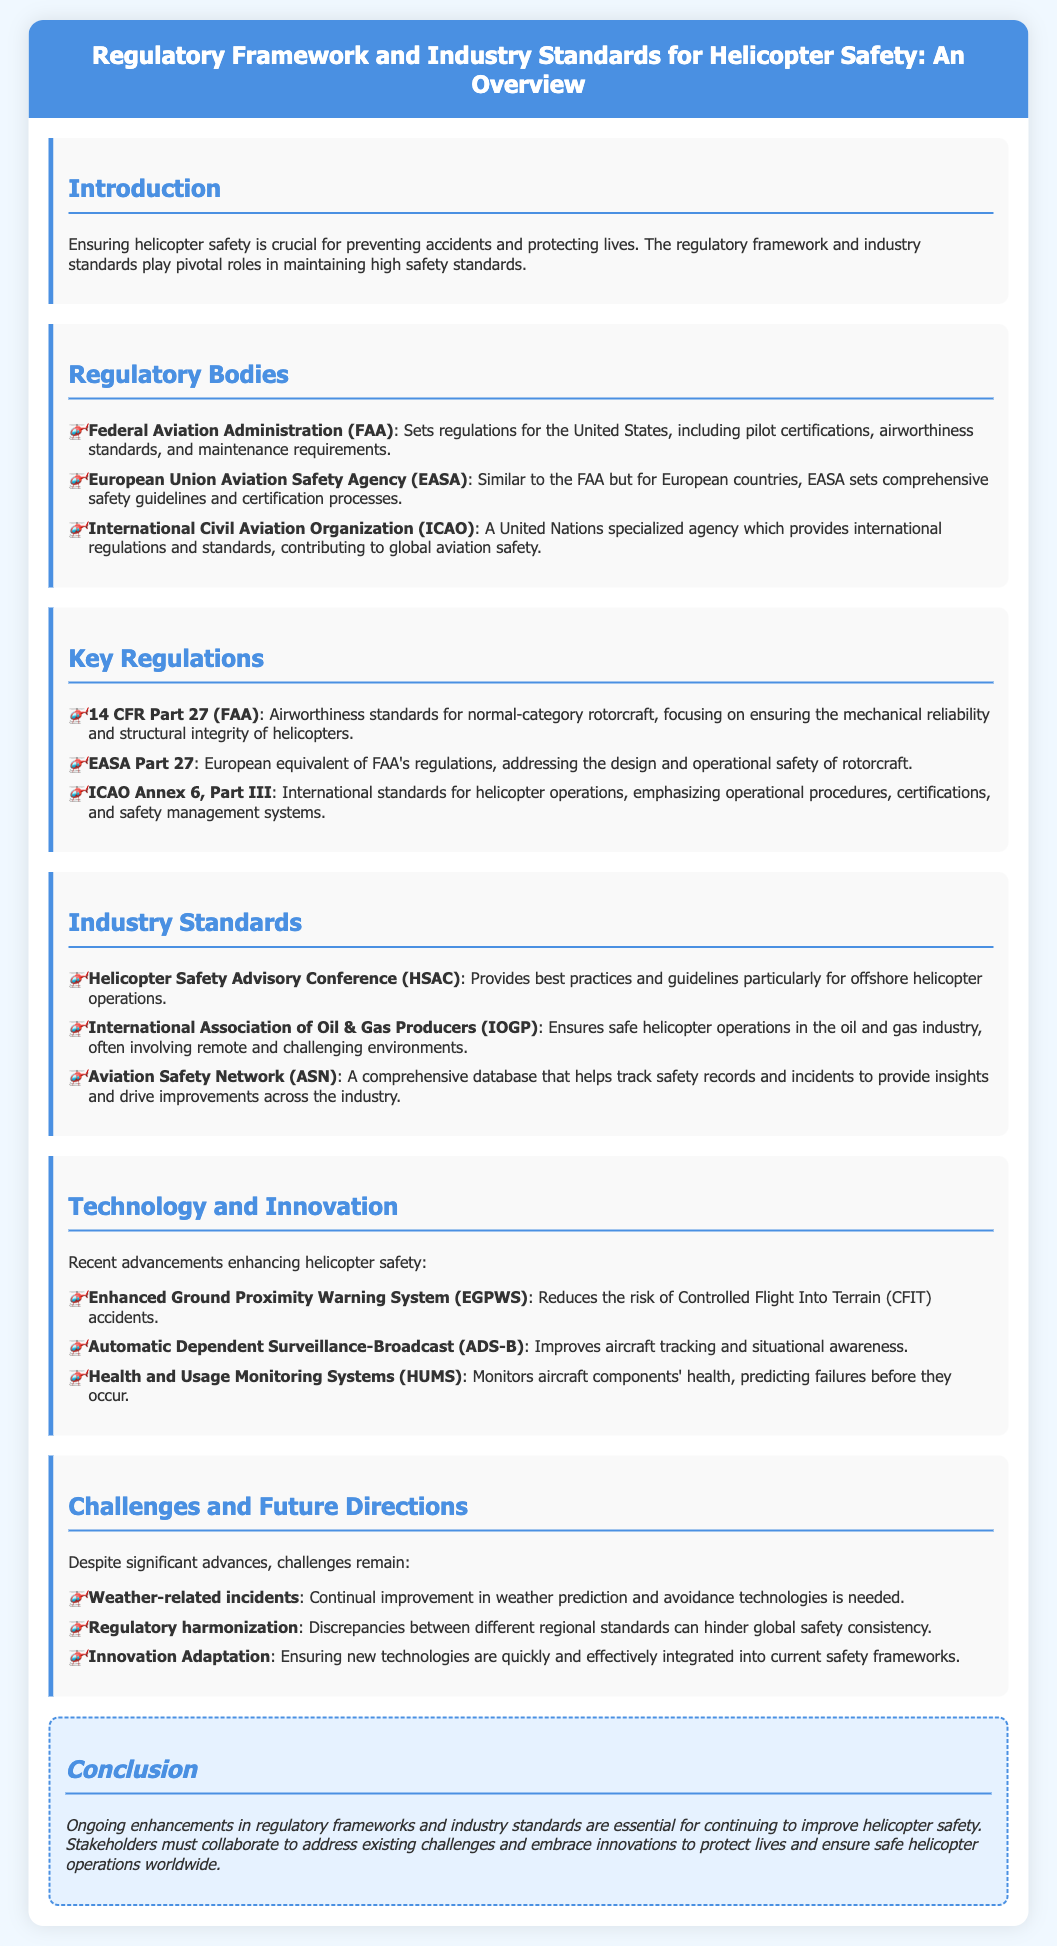What are the main regulatory bodies for helicopter safety? The document lists the regulatory bodies that influence helicopter safety, including FAA, EASA, and ICAO.
Answer: FAA, EASA, ICAO What is the primary focus of 14 CFR Part 27? The document states that 14 CFR Part 27 focuses on ensuring the mechanical reliability and structural integrity of helicopters.
Answer: Mechanical reliability and structural integrity What does the HSAC provide? The Helicopter Safety Advisory Conference provides best practices and guidelines for offshore helicopter operations.
Answer: Best practices and guidelines What advancement reduces the risk of Controlled Flight Into Terrain accidents? The document highlights EGPWS as a technology that reduces the risk of such accidents.
Answer: EGPWS What challenge is associated with regulatory harmonization? The document mentions that discrepancies between different regional standards can hinder global safety consistency.
Answer: Discrepancies between regional standards What is the role of the International Civil Aviation Organization? The ICAO provides international regulations and standards that contribute to global aviation safety.
Answer: International regulations and standards What does the acronym ADS-B stand for? The document references Automatic Dependent Surveillance-Broadcast as a critical safety technology.
Answer: Automatic Dependent Surveillance-Broadcast What type of incidents do weather-related challenges involve? The document indicates that weather-related incidents present continual challenges in helicopter safety.
Answer: Weather-related incidents 